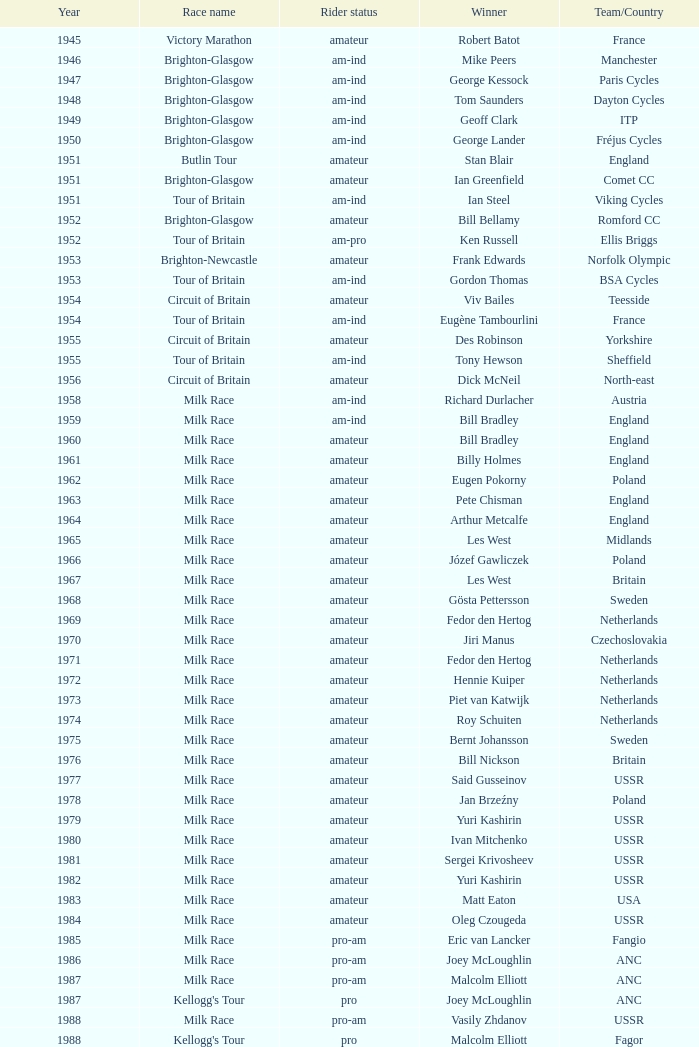Which team participated in the kellogg's tour after 1958? ANC, Fagor, Z-Peugeot, Weinnmann-SMM, Motorola, Motorola, Motorola, Lampre. Can you give me this table as a dict? {'header': ['Year', 'Race name', 'Rider status', 'Winner', 'Team/Country'], 'rows': [['1945', 'Victory Marathon', 'amateur', 'Robert Batot', 'France'], ['1946', 'Brighton-Glasgow', 'am-ind', 'Mike Peers', 'Manchester'], ['1947', 'Brighton-Glasgow', 'am-ind', 'George Kessock', 'Paris Cycles'], ['1948', 'Brighton-Glasgow', 'am-ind', 'Tom Saunders', 'Dayton Cycles'], ['1949', 'Brighton-Glasgow', 'am-ind', 'Geoff Clark', 'ITP'], ['1950', 'Brighton-Glasgow', 'am-ind', 'George Lander', 'Fréjus Cycles'], ['1951', 'Butlin Tour', 'amateur', 'Stan Blair', 'England'], ['1951', 'Brighton-Glasgow', 'amateur', 'Ian Greenfield', 'Comet CC'], ['1951', 'Tour of Britain', 'am-ind', 'Ian Steel', 'Viking Cycles'], ['1952', 'Brighton-Glasgow', 'amateur', 'Bill Bellamy', 'Romford CC'], ['1952', 'Tour of Britain', 'am-pro', 'Ken Russell', 'Ellis Briggs'], ['1953', 'Brighton-Newcastle', 'amateur', 'Frank Edwards', 'Norfolk Olympic'], ['1953', 'Tour of Britain', 'am-ind', 'Gordon Thomas', 'BSA Cycles'], ['1954', 'Circuit of Britain', 'amateur', 'Viv Bailes', 'Teesside'], ['1954', 'Tour of Britain', 'am-ind', 'Eugène Tambourlini', 'France'], ['1955', 'Circuit of Britain', 'amateur', 'Des Robinson', 'Yorkshire'], ['1955', 'Tour of Britain', 'am-ind', 'Tony Hewson', 'Sheffield'], ['1956', 'Circuit of Britain', 'amateur', 'Dick McNeil', 'North-east'], ['1958', 'Milk Race', 'am-ind', 'Richard Durlacher', 'Austria'], ['1959', 'Milk Race', 'am-ind', 'Bill Bradley', 'England'], ['1960', 'Milk Race', 'amateur', 'Bill Bradley', 'England'], ['1961', 'Milk Race', 'amateur', 'Billy Holmes', 'England'], ['1962', 'Milk Race', 'amateur', 'Eugen Pokorny', 'Poland'], ['1963', 'Milk Race', 'amateur', 'Pete Chisman', 'England'], ['1964', 'Milk Race', 'amateur', 'Arthur Metcalfe', 'England'], ['1965', 'Milk Race', 'amateur', 'Les West', 'Midlands'], ['1966', 'Milk Race', 'amateur', 'Józef Gawliczek', 'Poland'], ['1967', 'Milk Race', 'amateur', 'Les West', 'Britain'], ['1968', 'Milk Race', 'amateur', 'Gösta Pettersson', 'Sweden'], ['1969', 'Milk Race', 'amateur', 'Fedor den Hertog', 'Netherlands'], ['1970', 'Milk Race', 'amateur', 'Jiri Manus', 'Czechoslovakia'], ['1971', 'Milk Race', 'amateur', 'Fedor den Hertog', 'Netherlands'], ['1972', 'Milk Race', 'amateur', 'Hennie Kuiper', 'Netherlands'], ['1973', 'Milk Race', 'amateur', 'Piet van Katwijk', 'Netherlands'], ['1974', 'Milk Race', 'amateur', 'Roy Schuiten', 'Netherlands'], ['1975', 'Milk Race', 'amateur', 'Bernt Johansson', 'Sweden'], ['1976', 'Milk Race', 'amateur', 'Bill Nickson', 'Britain'], ['1977', 'Milk Race', 'amateur', 'Said Gusseinov', 'USSR'], ['1978', 'Milk Race', 'amateur', 'Jan Brzeźny', 'Poland'], ['1979', 'Milk Race', 'amateur', 'Yuri Kashirin', 'USSR'], ['1980', 'Milk Race', 'amateur', 'Ivan Mitchenko', 'USSR'], ['1981', 'Milk Race', 'amateur', 'Sergei Krivosheev', 'USSR'], ['1982', 'Milk Race', 'amateur', 'Yuri Kashirin', 'USSR'], ['1983', 'Milk Race', 'amateur', 'Matt Eaton', 'USA'], ['1984', 'Milk Race', 'amateur', 'Oleg Czougeda', 'USSR'], ['1985', 'Milk Race', 'pro-am', 'Eric van Lancker', 'Fangio'], ['1986', 'Milk Race', 'pro-am', 'Joey McLoughlin', 'ANC'], ['1987', 'Milk Race', 'pro-am', 'Malcolm Elliott', 'ANC'], ['1987', "Kellogg's Tour", 'pro', 'Joey McLoughlin', 'ANC'], ['1988', 'Milk Race', 'pro-am', 'Vasily Zhdanov', 'USSR'], ['1988', "Kellogg's Tour", 'pro', 'Malcolm Elliott', 'Fagor'], ['1989', 'Milk Race', 'pro-am', 'Brian Walton', '7-Eleven'], ['1989', "Kellogg's Tour", 'pro', 'Robert Millar', 'Z-Peugeot'], ['1990', 'Milk Race', 'pro-am', 'Shane Sutton', 'Banana'], ['1990', "Kellogg's Tour", 'pro', 'Michel Dernies', 'Weinnmann-SMM'], ['1991', 'Milk Race', 'pro-am', 'Chris Walker', 'Banana'], ['1991', "Kellogg's Tour", 'pro', 'Phil Anderson', 'Motorola'], ['1992', 'Milk Race', 'pro-am', 'Conor Henry', 'Ireland'], ['1992', "Kellogg's Tour", 'pro', 'Max Sciandri', 'Motorola'], ['1993', 'Milk Race', 'pro-am', 'Chris Lillywhite', 'Banana'], ['1993', "Kellogg's Tour", 'pro', 'Phil Anderson', 'Motorola'], ['1994', "Kellogg's Tour", 'pro', 'Maurizio Fondriest', 'Lampre'], ['1998', 'PruTour', 'pro', "Stuart O'Grady", 'Crédit Agricole'], ['1999', 'PruTour', 'pro', 'Marc Wauters', 'Rabobank']]} 